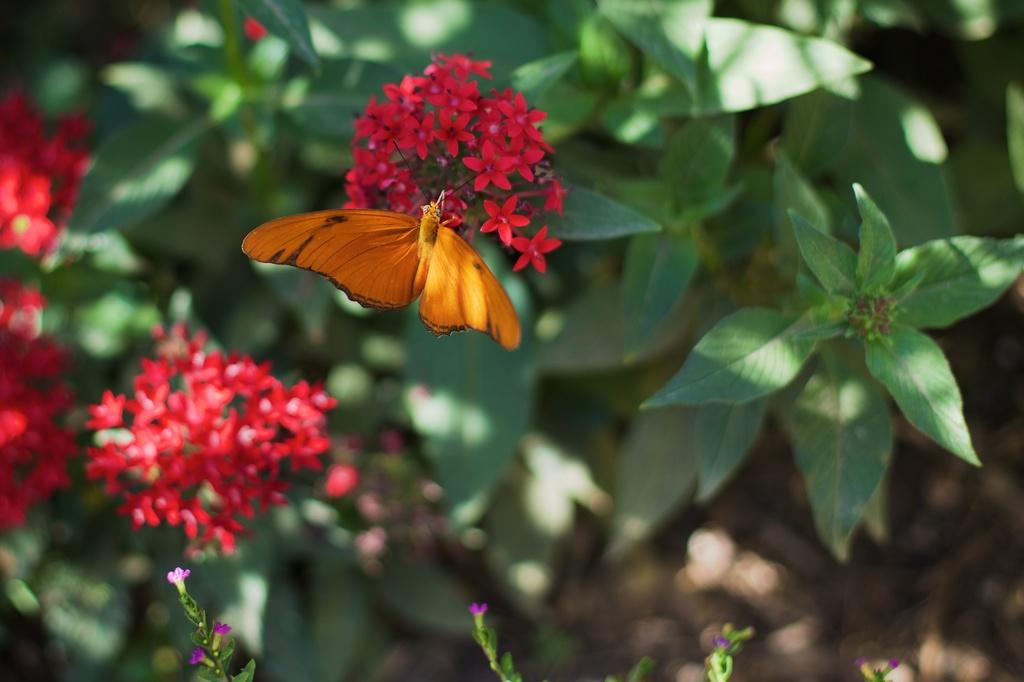What type of creature can be seen in the image? There is an insect, possibly a butterfly, in the image. Where is the insect located in the image? The insect is on flowers in the image. What other elements can be seen in the image besides the insect? There are leaves and plants visible in the image. What type of tin can be seen in the image? There is no tin present in the image. Can you describe the flight of the insect in the image? The image is a still photograph, so it does not show the insect in flight. 